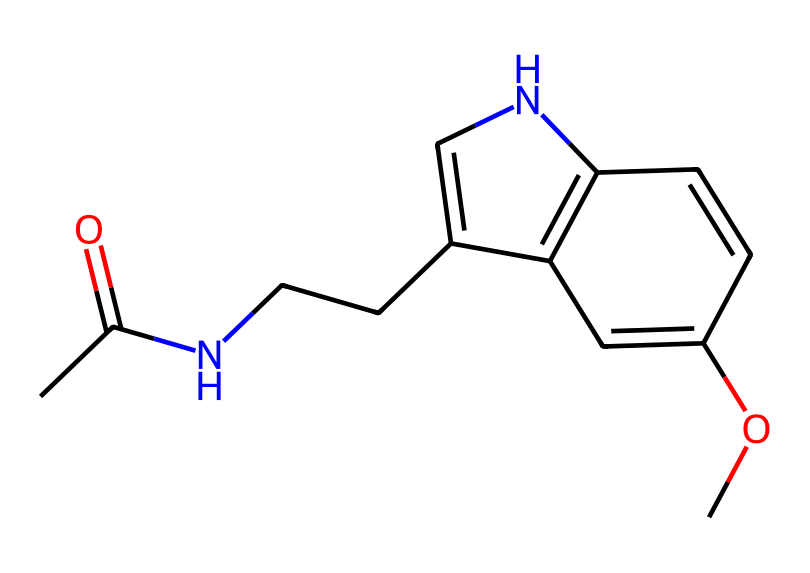How many carbon atoms are in melatonin? By analyzing the SMILES representation, we can identify carbon atoms denoted by "C" in the string. Each "C" not followed by a number represents one carbon atom. Counting all the "C" notations in the SMILES yields 13 carbon atoms.
Answer: 13 What is the primary functional group in melatonin? The SMILES representation shows a "CC(=O)" at the beginning, indicating a carbonyl group (C=O). This confirms the presence of an acetamide functional group, which is the characteristic functional group of melatonin.
Answer: acetamide How many nitrogen atoms are present in the chemical? In the SMILES representation, the nitrogen atoms are represented by "N" and "n". There are two such instances present, resulting in a total count of two nitrogen atoms.
Answer: 2 What type of molecule is melatonin classified as? Given its structure, melatonin shows characteristics of an indole derivative, which is indicative of a neurotransmitter and hormone related to the regulation of sleep, classifying it as a neurohormone.
Answer: neurohormone Which bond type appears most frequently in melatonin's structure? The structure contains multiple instances of single bonds (denoted by the absence of any symbols between atoms) compared to double bonds (e.g., "=" for C=O). Counting reveals that single bonds dominate, indicating that they are the most frequent bond type.
Answer: single bonds How many rings are in the structure of melatonin? Analyzing the representation, we notice parts of the structure that form closed pathways, particularly the "c" notations indicating aromatic carbon rings. There is one indolic ring structure in melatonin, leading to a total of one ring in its configuration.
Answer: 1 Is melatonin likely to be polar or nonpolar? Based on the presence of polar functional groups, such as the acetamide group (C=O and N), and the overall configuration of the molecule, it would exhibit characteristics of a polar molecule due to the unequal distribution of electron density.
Answer: polar 